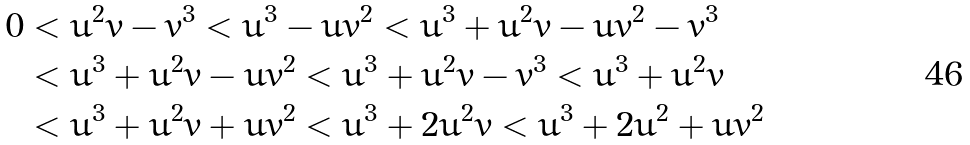Convert formula to latex. <formula><loc_0><loc_0><loc_500><loc_500>0 & < u ^ { 2 } v - v ^ { 3 } < u ^ { 3 } - u v ^ { 2 } < u ^ { 3 } + u ^ { 2 } v - u v ^ { 2 } - v ^ { 3 } \\ & < u ^ { 3 } + u ^ { 2 } v - u v ^ { 2 } < u ^ { 3 } + u ^ { 2 } v - v ^ { 3 } < u ^ { 3 } + u ^ { 2 } v \\ & < u ^ { 3 } + u ^ { 2 } v + u v ^ { 2 } < u ^ { 3 } + 2 u ^ { 2 } v < u ^ { 3 } + 2 u ^ { 2 } + u v ^ { 2 }</formula> 